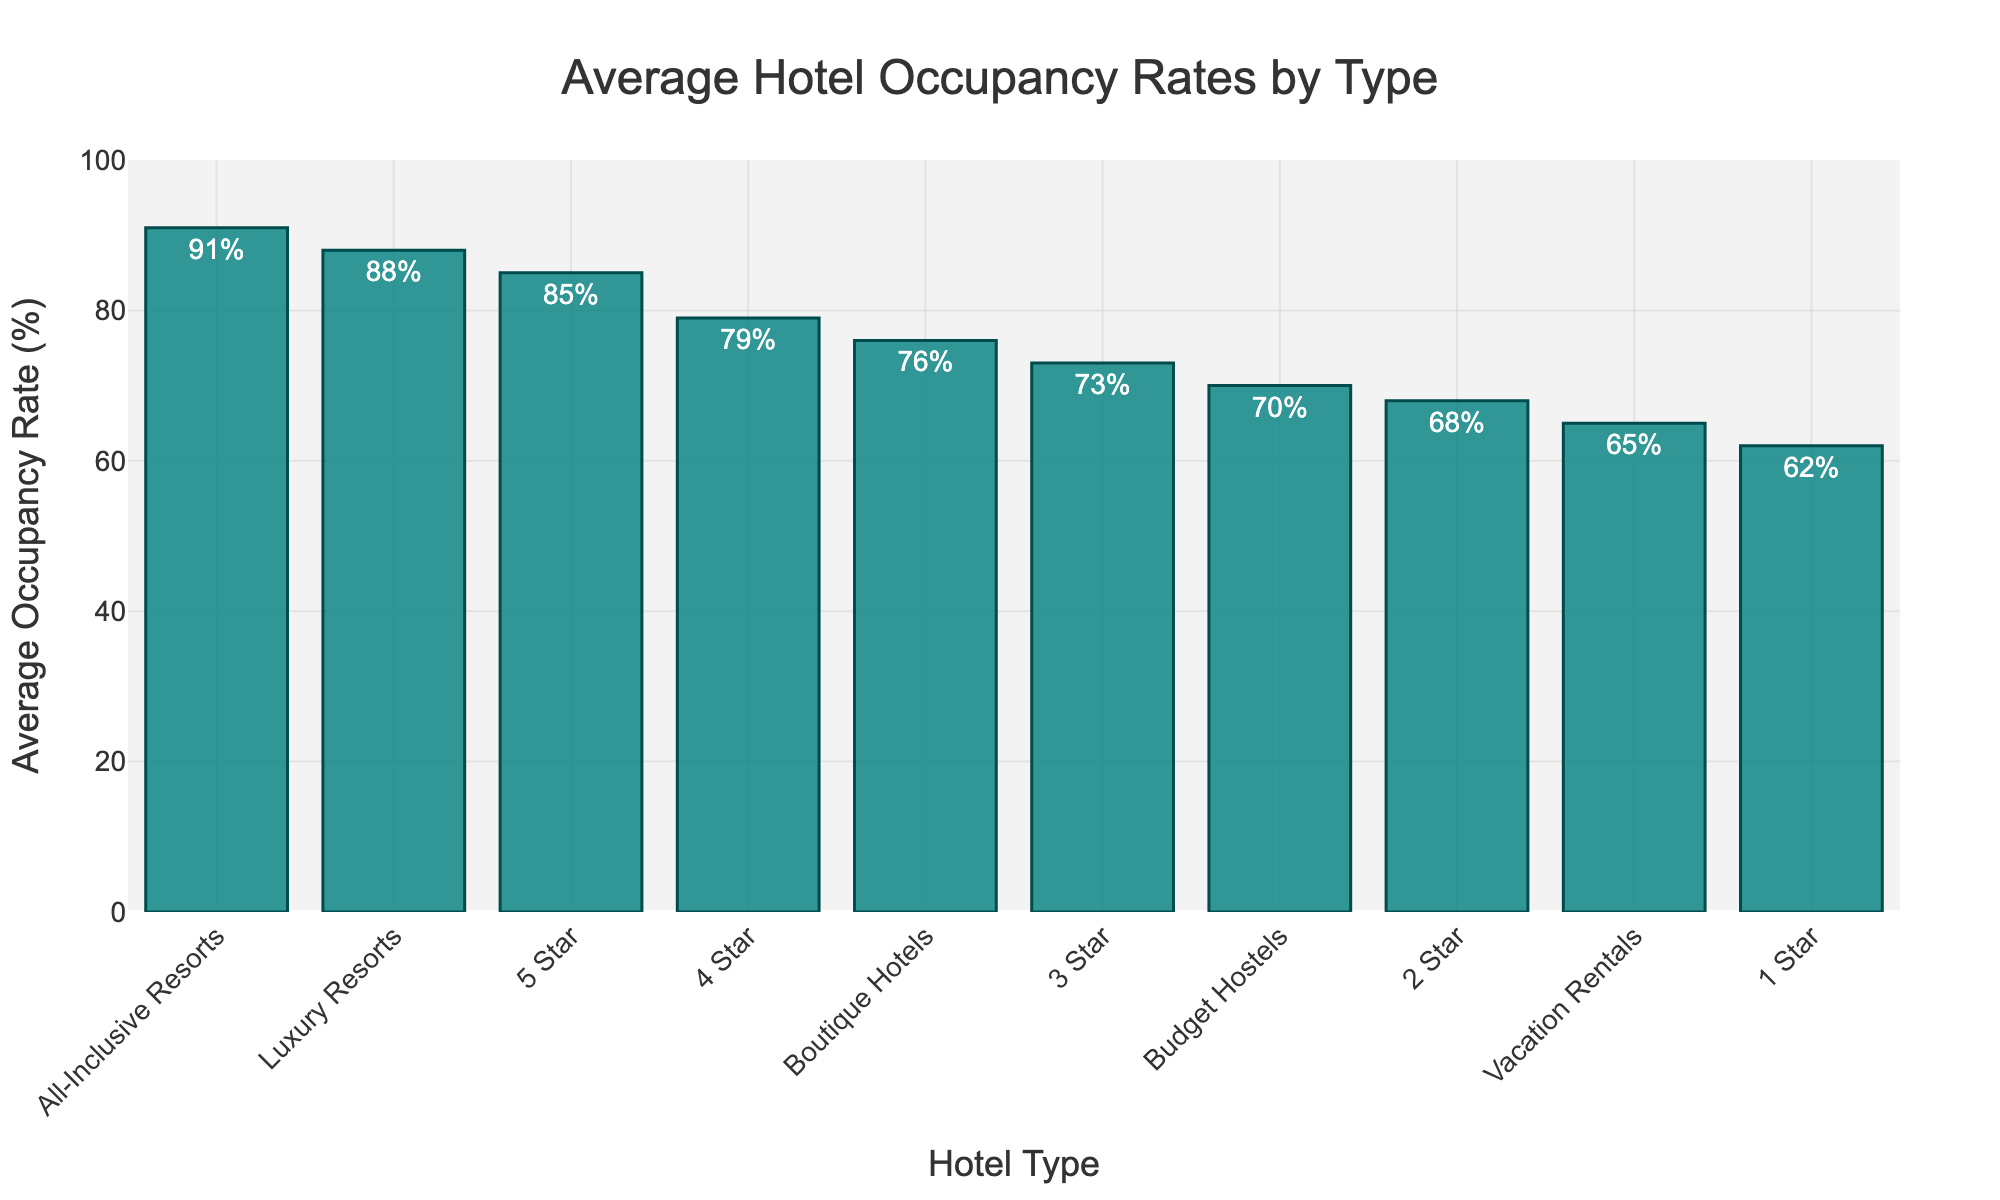What's the highest average occupancy rate among the different hotel types and categories? Look for the tallest bar in the chart, as it represents the highest average occupancy rate. "All-Inclusive Resorts" has the tallest bar with an occupancy rate of 91%.
Answer: 91% Which type of hotel has the lowest average occupancy rate? Identify the shortest bar in the chart to find the lowest average occupancy rate. "1 Star" hotels have the shortest bar with 62%.
Answer: 1 Star How does the average occupancy rate of Boutique Hotels compare to 4 Star hotels? Find the heights of the bars for Boutique Hotels and 4 Star hotels and compare them. The Boutique Hotels have an occupancy rate of 76%, and the 4 Star hotels have an occupancy rate of 79%, so the 4 Star hotels have a higher rate.
Answer: 4 Star hotels have a higher rate What is the difference in average occupancy rates between Luxury Resorts and Budget Hostels? Locate the bars for Luxury Resorts and Budget Hostels, note their values, and subtract the smaller from the larger. Luxury Resorts have 88%, while Budget Hostels have 70%. The difference is 88% - 70% = 18%.
Answer: 18% What's the sum of the average occupancy rates for 2 Star, 3 Star, and Vacation Rentals? Find and add the occupancy rates for 2 Star (68%), 3 Star (73%), and Vacation Rentals (65%). 68 + 73 + 65 = 206%.
Answer: 206% Which hotels have an occupancy rate greater than 75%? Check which bars are taller than the 75% mark on the y-axis. The hotels are 3 Star (73%), 4 Star (79%), 5 Star (85%), Luxury Resorts (88%), and All-Inclusive Resorts (91%).
Answer: 4 Star, 5 Star, Luxury Resorts, All-Inclusive Resorts What is the combined average occupancy rate for 4 Star and 5 Star hotels? Add the occupancy rates of 4 Star and 5 Star hotels. 4 Star has 79% and 5 Star has 85%. The combined rate is 79 + 85 = 164%.
Answer: 164% By how much does the occupancy rate of Vacation Rentals differ from Budget Hostels? Subtract the occupancy rate of Vacation Rentals (65%) from Budget Hostels (70%). The difference is 70% - 65% = 5%.
Answer: 5% Does any hotel type have an occupancy rate exactly at 75%? Look for a bar that reaches the exact 75% mark. No hotel type is exactly at 75%; the closest are Boutique Hotels at 76% and 3 Star hotels at 73%.
Answer: No If the occupancy rate of Budget Hostels increased by 10%, what would be their new rate? Add 10% to the current occupancy rate of Budget Hostels, which is 70%. 70% + 10% = 80%.
Answer: 80% 